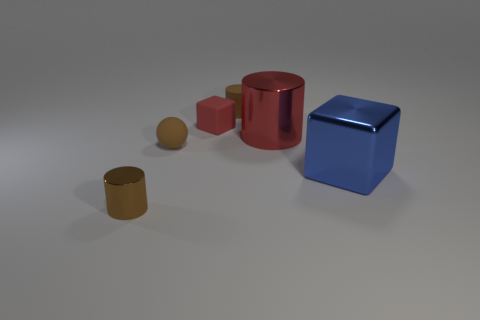Add 2 large things. How many objects exist? 8 Subtract all cubes. How many objects are left? 4 Subtract 1 blue cubes. How many objects are left? 5 Subtract all big red cylinders. Subtract all big blue shiny things. How many objects are left? 4 Add 3 tiny brown matte objects. How many tiny brown matte objects are left? 5 Add 3 big blue metallic cubes. How many big blue metallic cubes exist? 4 